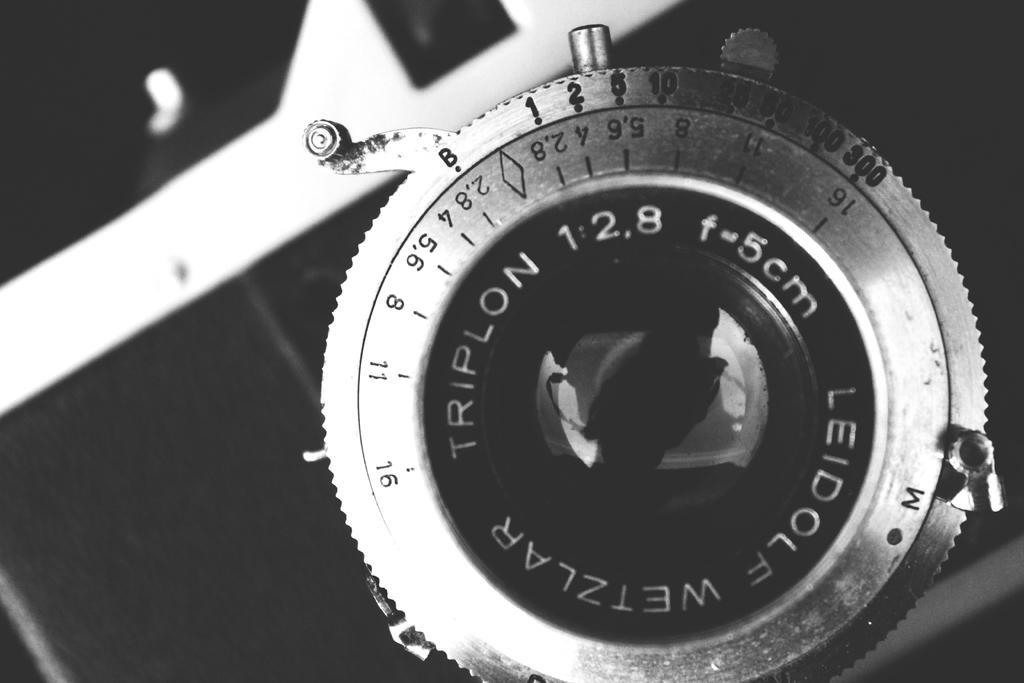Please provide a concise description of this image. In this picture I can see there is a camera lens and there is something written around it and there are few markings and the camera is in black color. 